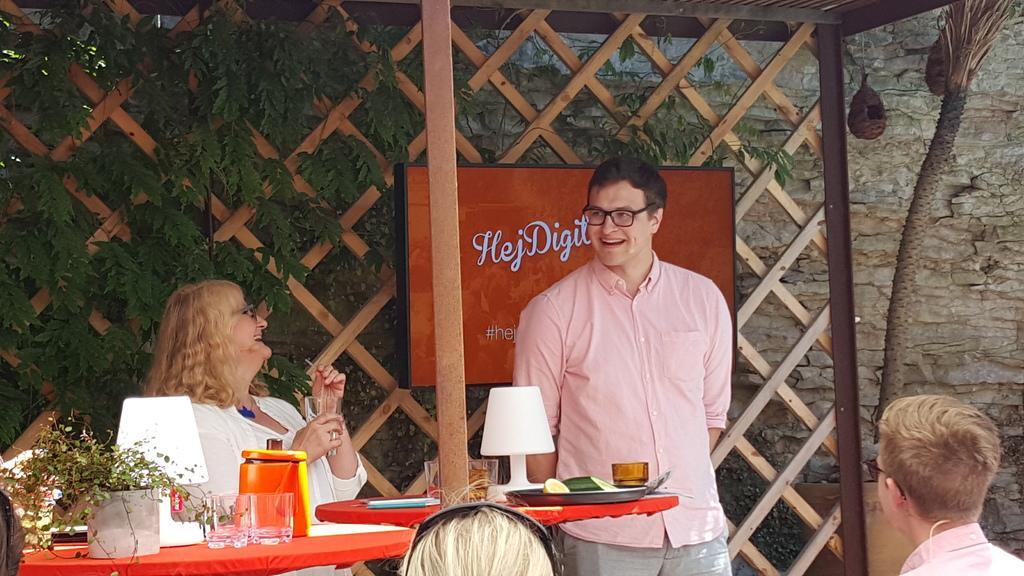Describe this image in one or two sentences. In this picture I can see a man standing and few people are sitting and I can see a plant and few glasses and a container and a lamp on the table and I can see a lamp and few glasses and a bowl in the plate on the another table and I can see trees and a television in the back displaying some text and I can see a woman holding a glass and a straw in her hands and I can see wall in the back. 